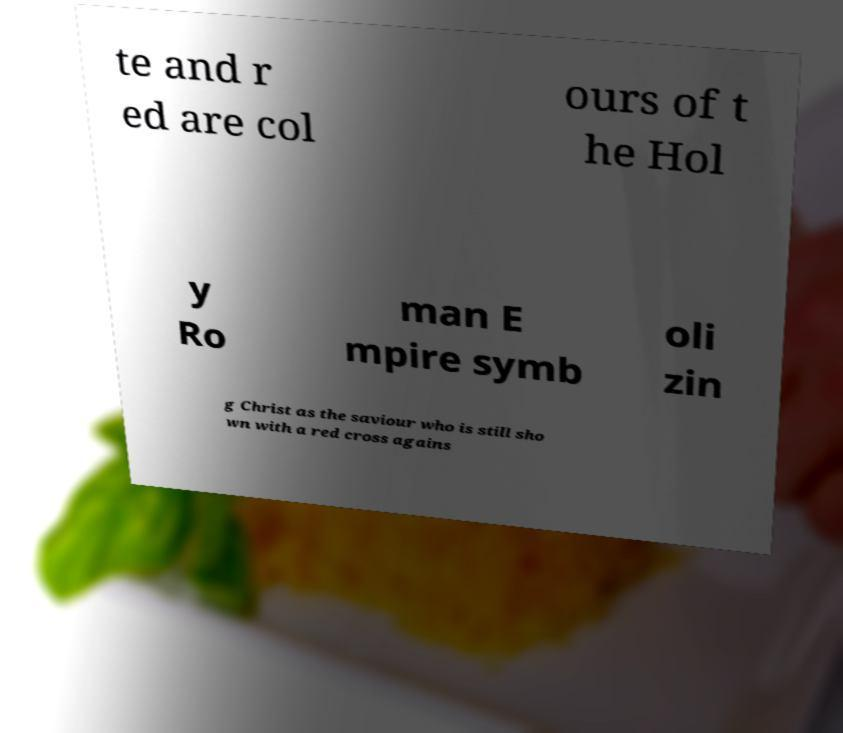There's text embedded in this image that I need extracted. Can you transcribe it verbatim? te and r ed are col ours of t he Hol y Ro man E mpire symb oli zin g Christ as the saviour who is still sho wn with a red cross agains 